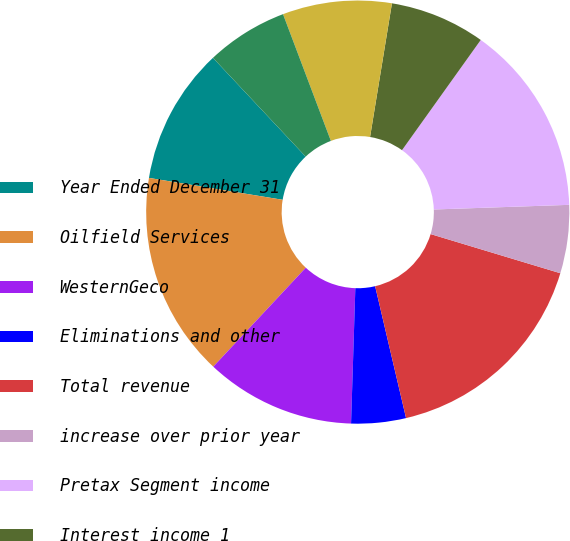<chart> <loc_0><loc_0><loc_500><loc_500><pie_chart><fcel>Year Ended December 31<fcel>Oilfield Services<fcel>WesternGeco<fcel>Eliminations and other<fcel>Total revenue<fcel>increase over prior year<fcel>Pretax Segment income<fcel>Interest income 1<fcel>Interest expense 1<fcel>Charges (credits) net 2<nl><fcel>10.42%<fcel>15.62%<fcel>11.46%<fcel>4.17%<fcel>16.67%<fcel>5.21%<fcel>14.58%<fcel>7.29%<fcel>8.33%<fcel>6.25%<nl></chart> 